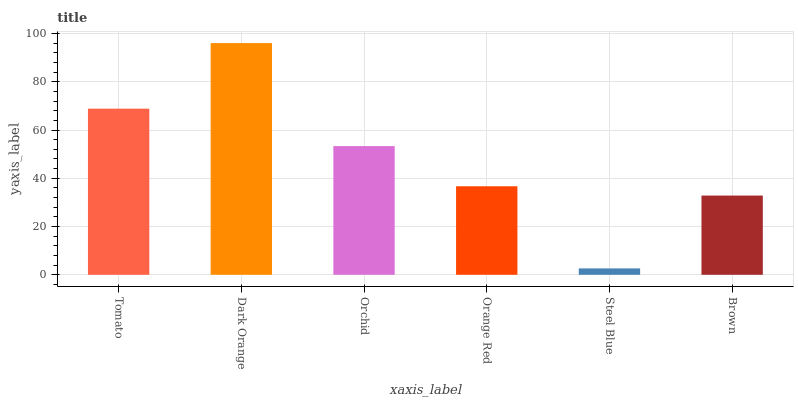Is Steel Blue the minimum?
Answer yes or no. Yes. Is Dark Orange the maximum?
Answer yes or no. Yes. Is Orchid the minimum?
Answer yes or no. No. Is Orchid the maximum?
Answer yes or no. No. Is Dark Orange greater than Orchid?
Answer yes or no. Yes. Is Orchid less than Dark Orange?
Answer yes or no. Yes. Is Orchid greater than Dark Orange?
Answer yes or no. No. Is Dark Orange less than Orchid?
Answer yes or no. No. Is Orchid the high median?
Answer yes or no. Yes. Is Orange Red the low median?
Answer yes or no. Yes. Is Brown the high median?
Answer yes or no. No. Is Dark Orange the low median?
Answer yes or no. No. 